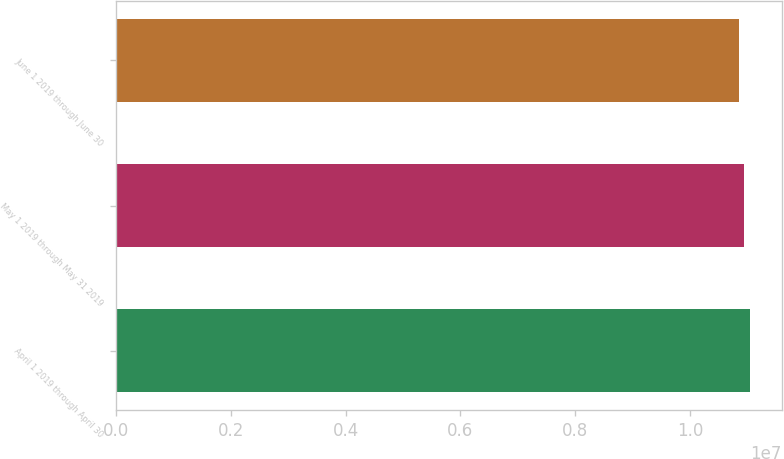<chart> <loc_0><loc_0><loc_500><loc_500><bar_chart><fcel>April 1 2019 through April 30<fcel>May 1 2019 through May 31 2019<fcel>June 1 2019 through June 30<nl><fcel>1.10461e+07<fcel>1.09431e+07<fcel>1.08468e+07<nl></chart> 